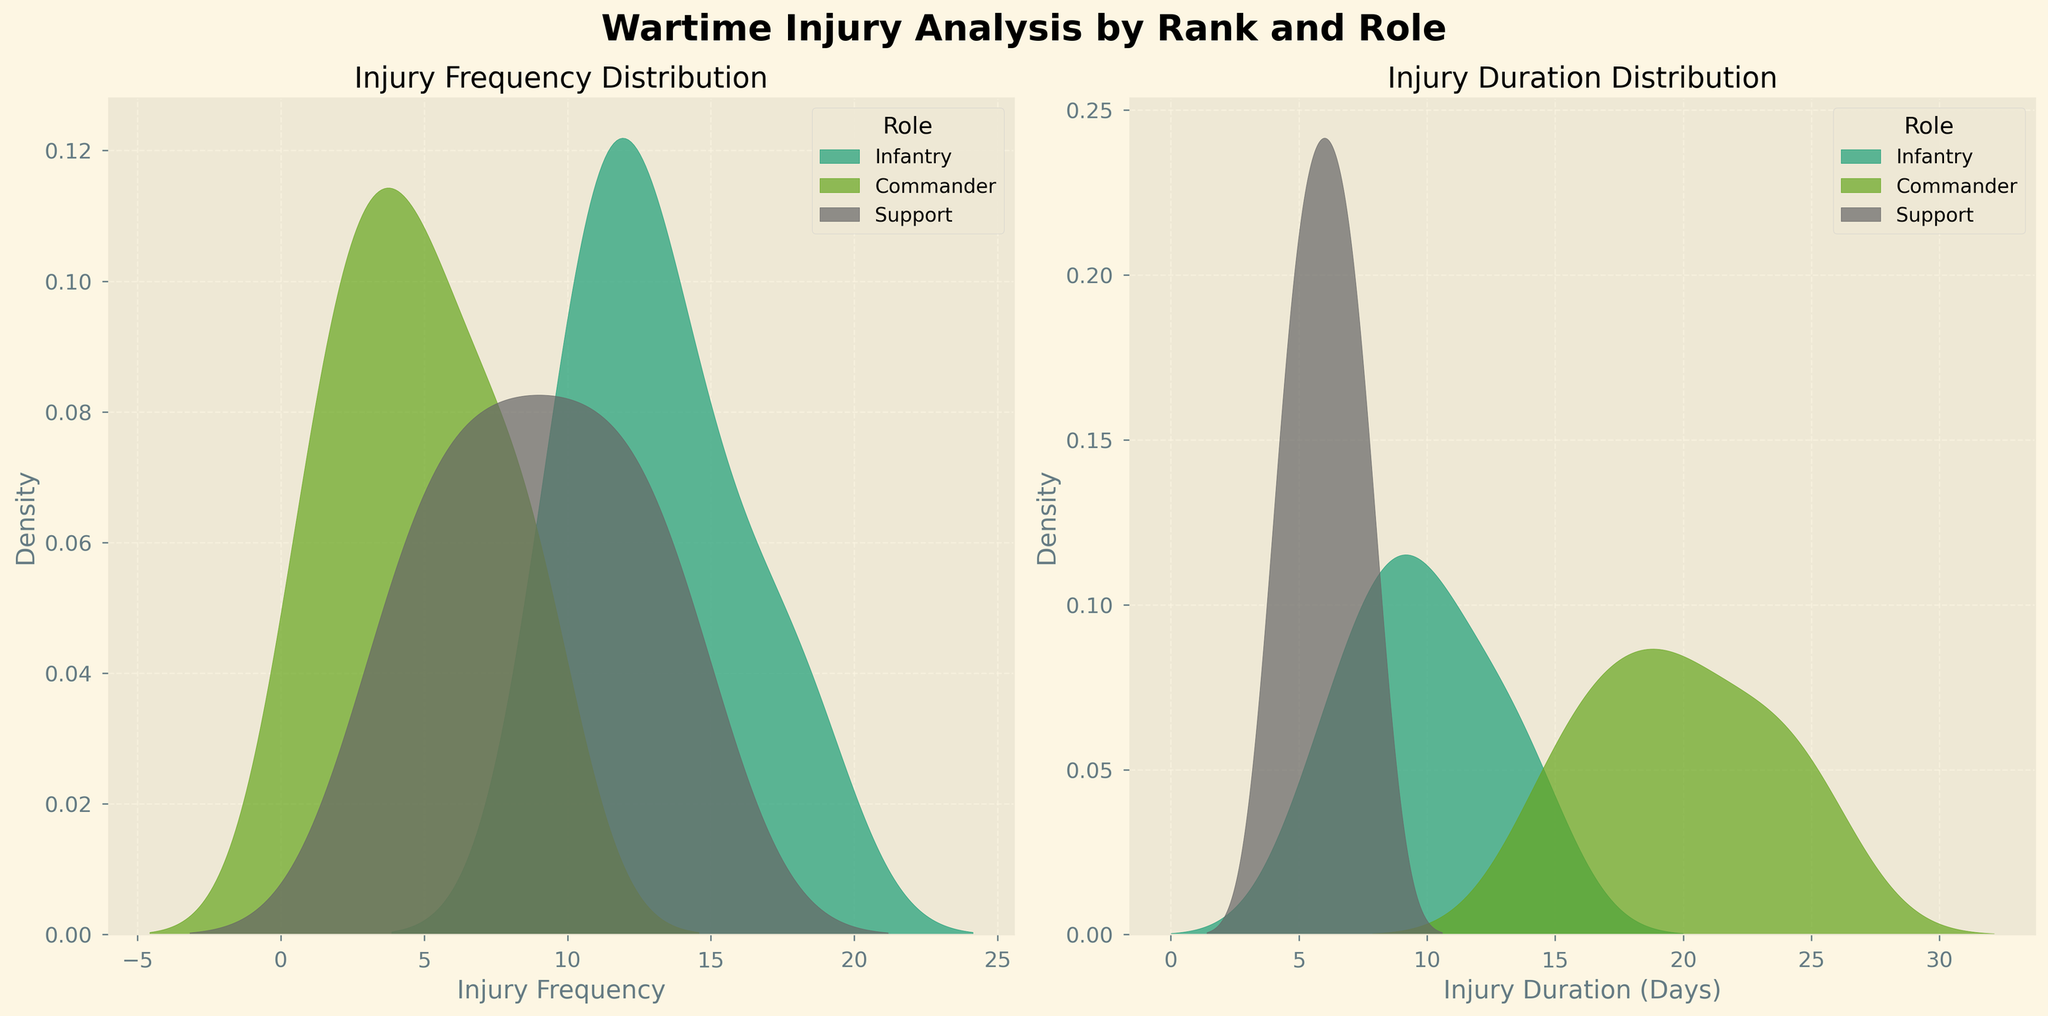Which role has the highest peak in injury frequency? To determine the role with the highest peak in injury frequency, look at the plot for Injury Frequency Distribution and identify which role's density curve reaches the highest point.
Answer: Infantry What is the approximate range of injury duration days for commanders? To find the approximate range for commanders, observe the plot for Injury Duration Distribution and see where the density curve for the Commander role starts and ends.
Answer: 1 to 25 days Do medics tend to have shorter or longer injury durations compared to commanders? Compare the density curves of Medics and Commanders in the Injury Duration Distribution plot. The Medic curve is more concentrated around shorter durations, while the Commander curve spreads to longer durations.
Answer: Shorter How does the injury frequency distribution for support roles compare to that of infantry roles? To compare the injury frequency distributions, look at the Injury Frequency Distribution plot. The curve for Support roles is more spread out and has multiple peaks at lower frequencies, while the Infantry curve is more concentrated and peaks higher.
Answer: More spread out with lower peaks Which role has the highest concentration of short injury durations? To identify the role with the highest concentration of short injury durations, observe the Injury Duration Distribution plot and see which role's curve is most concentrated on the left side (short durations).
Answer: Medics Which density curve for injury frequency is the narrowest? To identify the narrowest density curve for injury frequency, look for the curve with the least spread in the Injury Frequency Distribution plot.
Answer: Commanders 